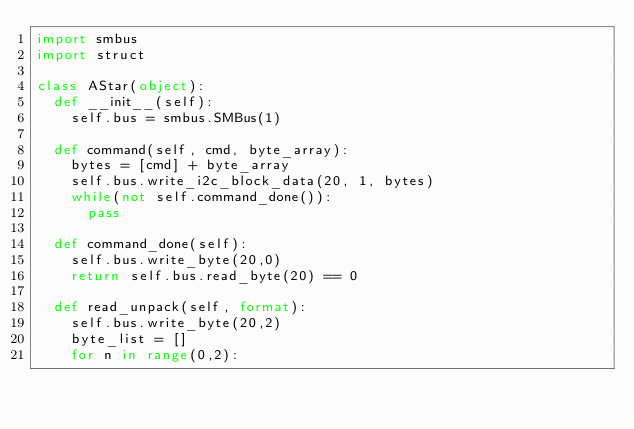Convert code to text. <code><loc_0><loc_0><loc_500><loc_500><_Python_>import smbus
import struct

class AStar(object):
  def __init__(self):
    self.bus = smbus.SMBus(1)

  def command(self, cmd, byte_array):
    bytes = [cmd] + byte_array
    self.bus.write_i2c_block_data(20, 1, bytes)
    while(not self.command_done()):
      pass

  def command_done(self):
    self.bus.write_byte(20,0)
    return self.bus.read_byte(20) == 0

  def read_unpack(self, format):
    self.bus.write_byte(20,2)
    byte_list = []
    for n in range(0,2):</code> 